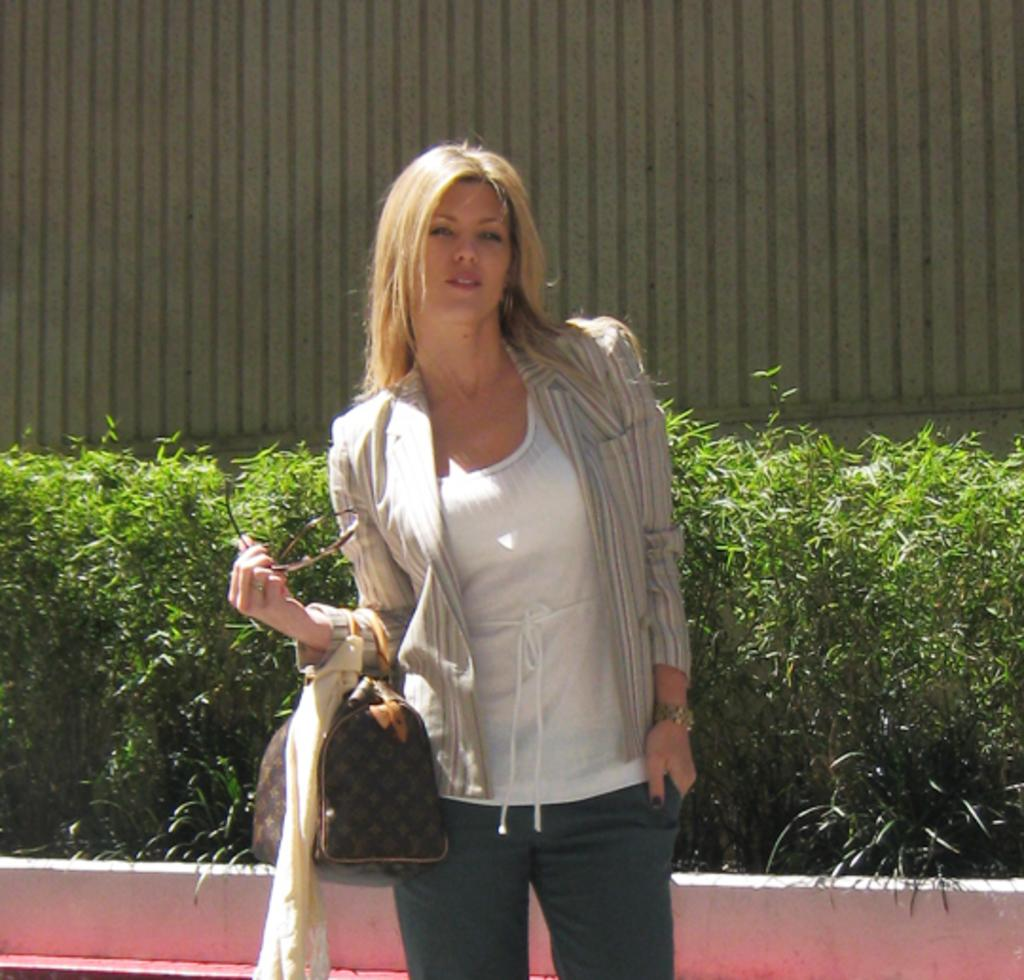Who is present in the image? There is a woman in the image. What is the woman holding? The woman is holding a handbag. What type of vegetation is visible behind the woman? There are bushes behind the woman. What structure can be seen behind the bushes? There is a wall visible behind the bushes. What type of chicken is sitting on the wall in the image? There is no chicken present in the image; it only features a woman, bushes, and a wall. 